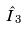Convert formula to latex. <formula><loc_0><loc_0><loc_500><loc_500>\hat { I } _ { 3 }</formula> 